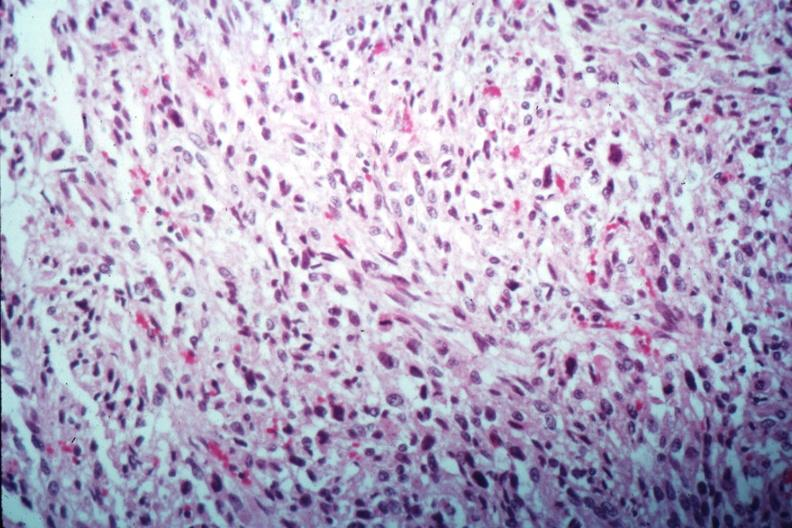s leiomyosarcoma present?
Answer the question using a single word or phrase. Yes 